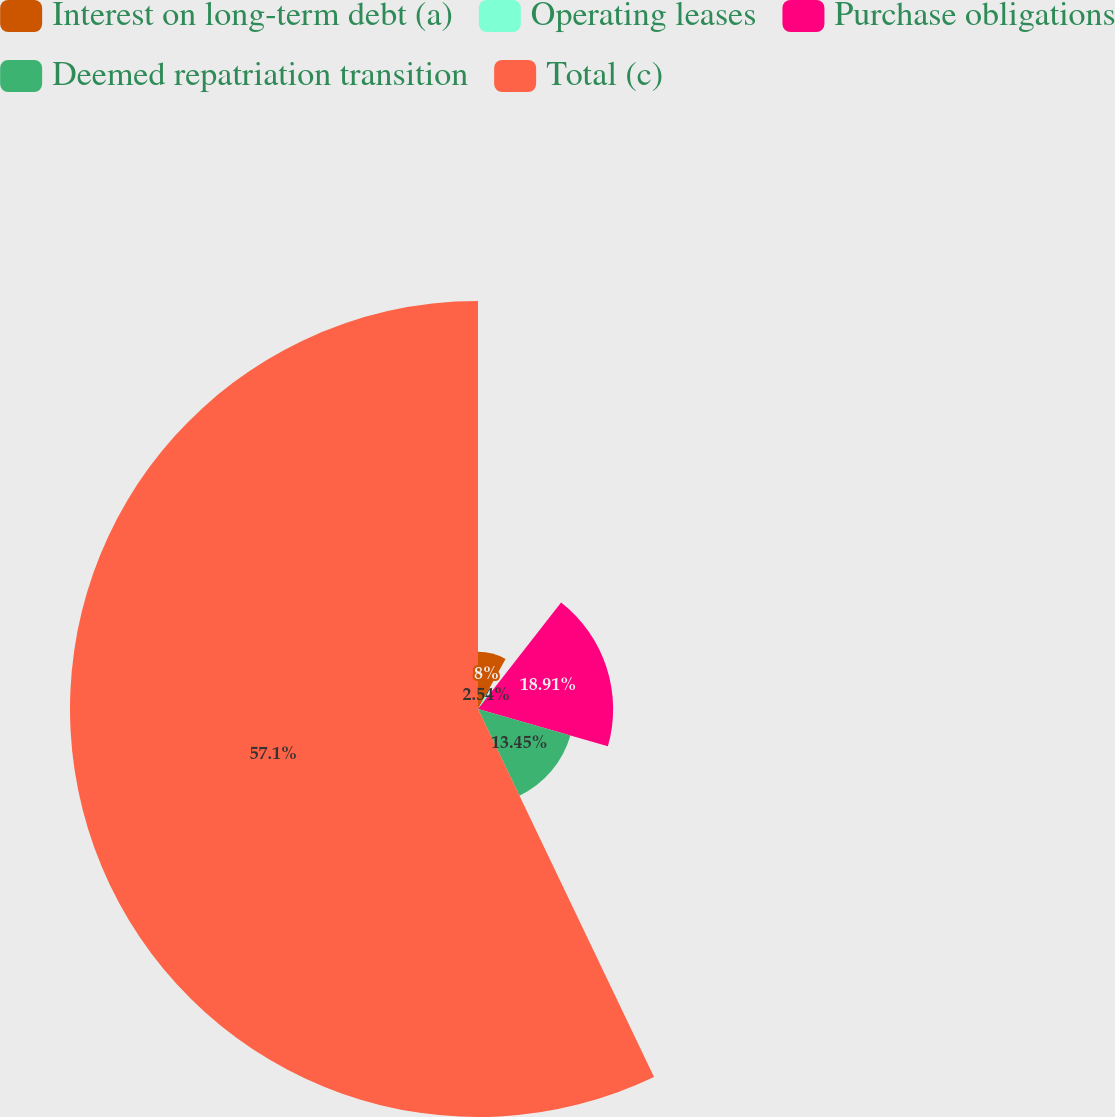Convert chart. <chart><loc_0><loc_0><loc_500><loc_500><pie_chart><fcel>Interest on long-term debt (a)<fcel>Operating leases<fcel>Purchase obligations<fcel>Deemed repatriation transition<fcel>Total (c)<nl><fcel>8.0%<fcel>2.54%<fcel>18.91%<fcel>13.45%<fcel>57.1%<nl></chart> 